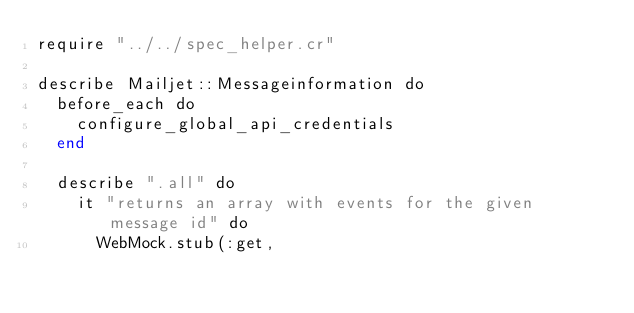<code> <loc_0><loc_0><loc_500><loc_500><_Crystal_>require "../../spec_helper.cr"

describe Mailjet::Messageinformation do
  before_each do
    configure_global_api_credentials
  end

  describe ".all" do
    it "returns an array with events for the given message id" do
      WebMock.stub(:get,</code> 